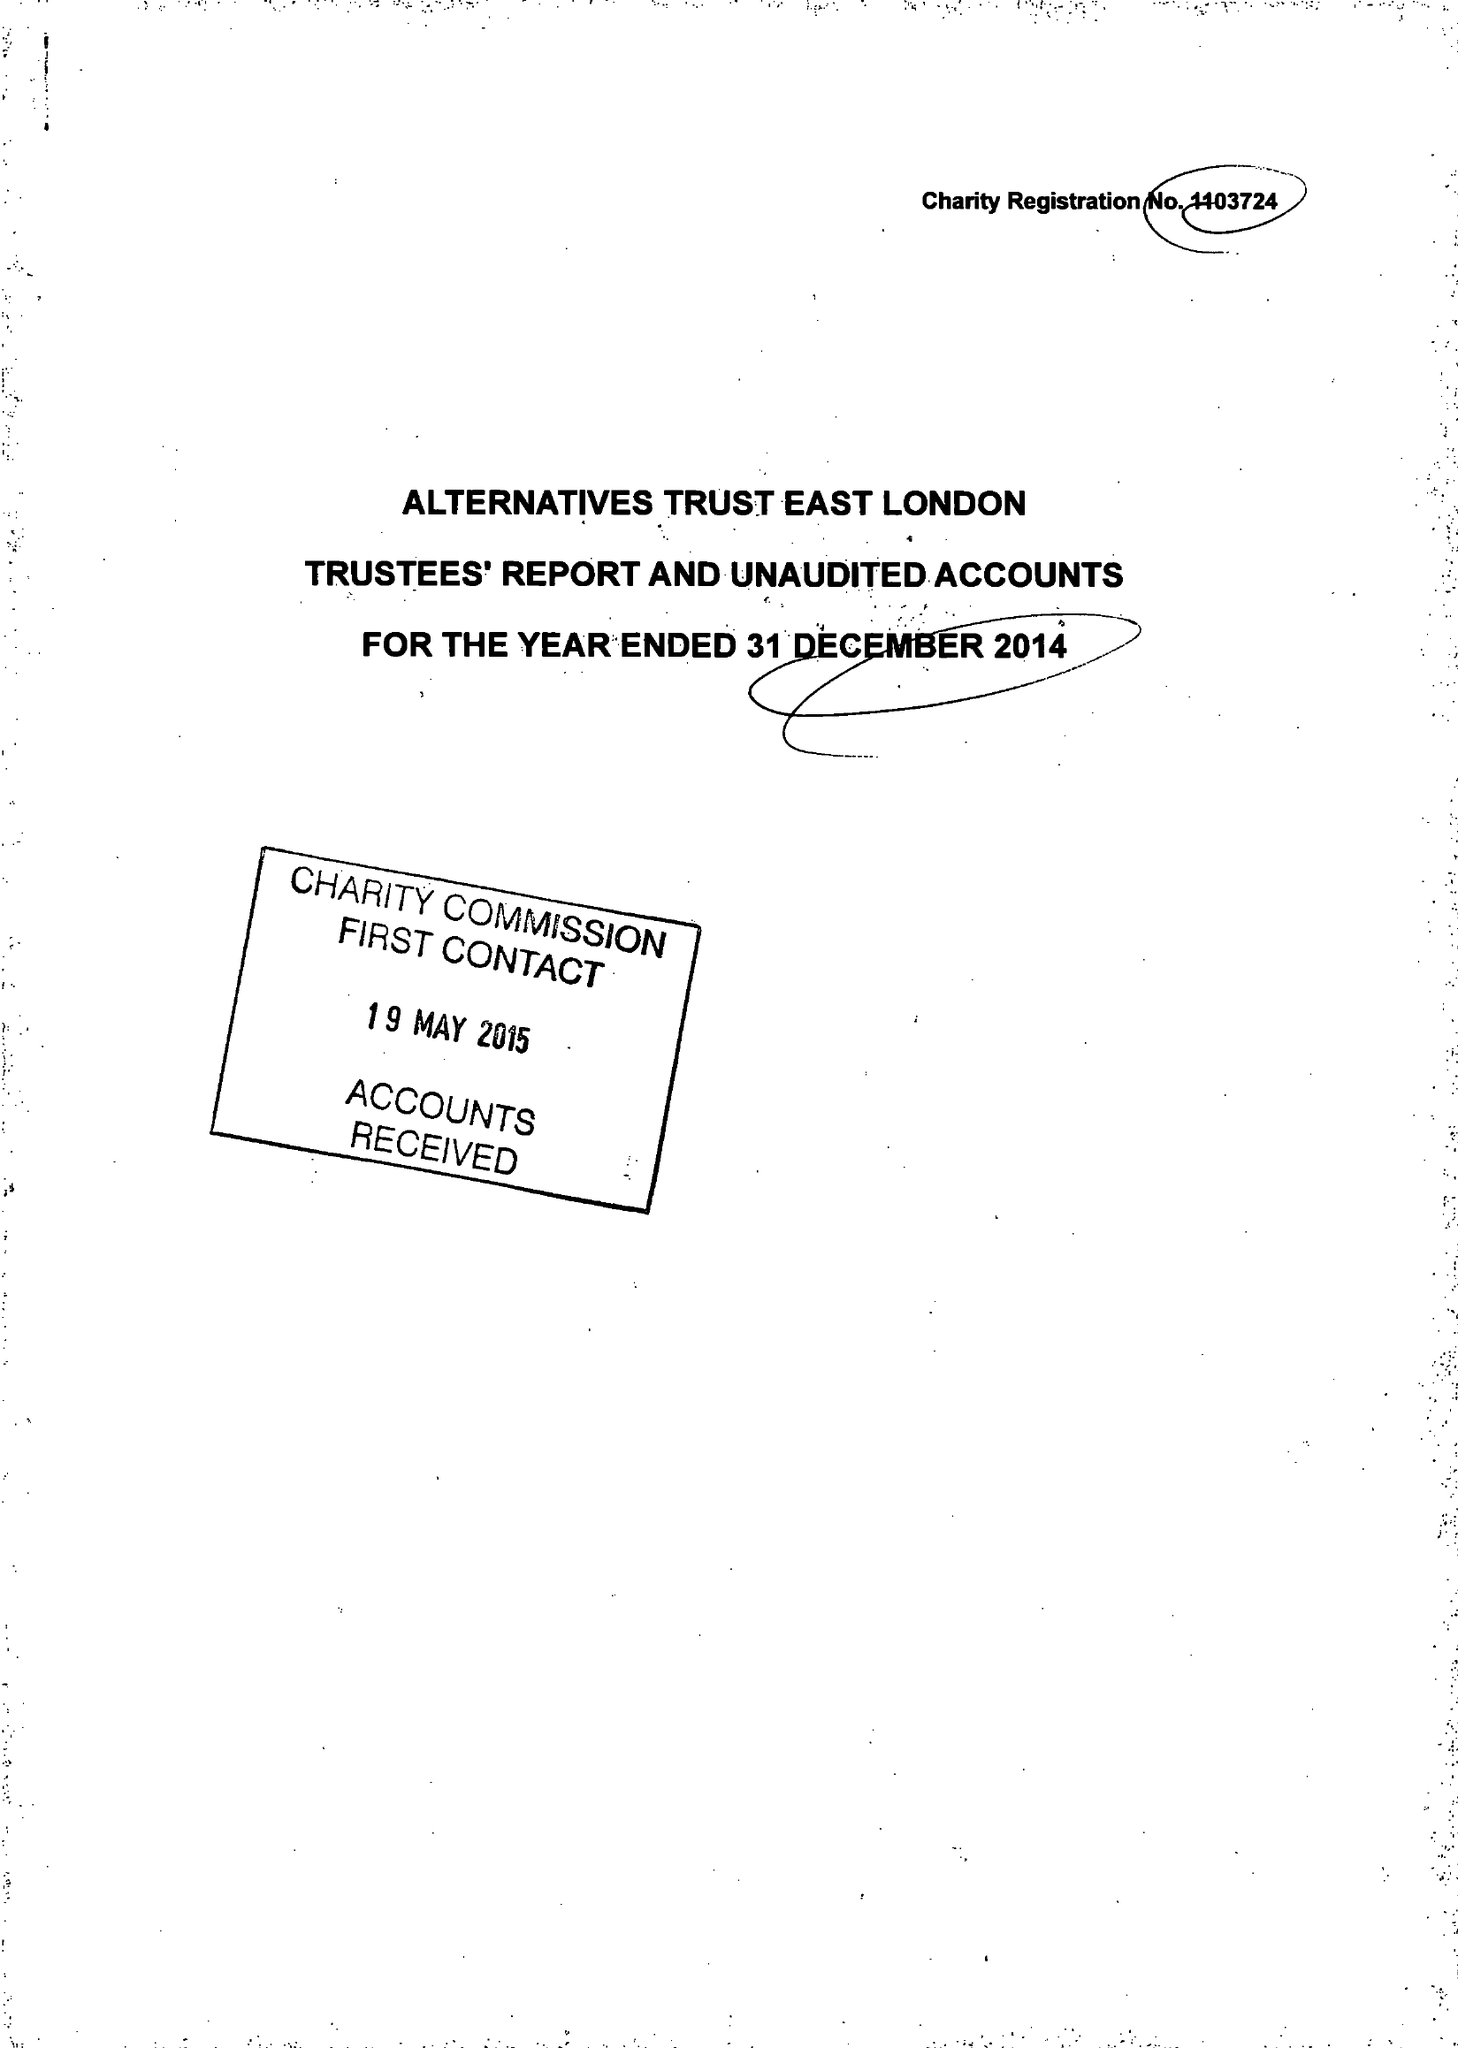What is the value for the income_annually_in_british_pounds?
Answer the question using a single word or phrase. 104334.00 